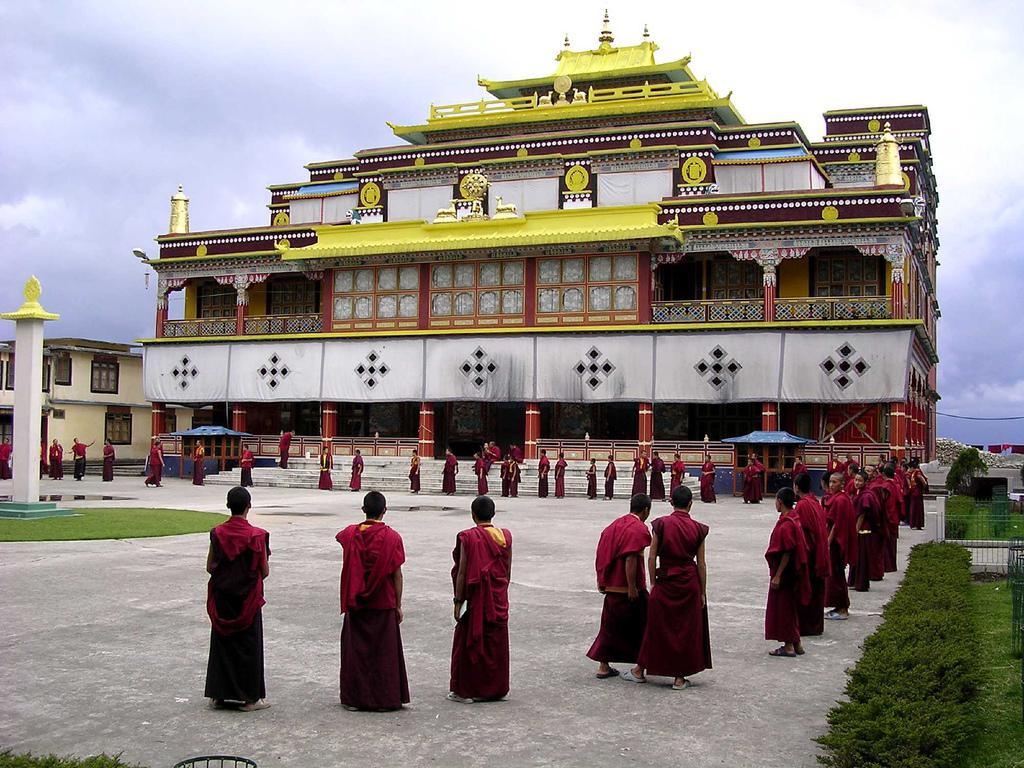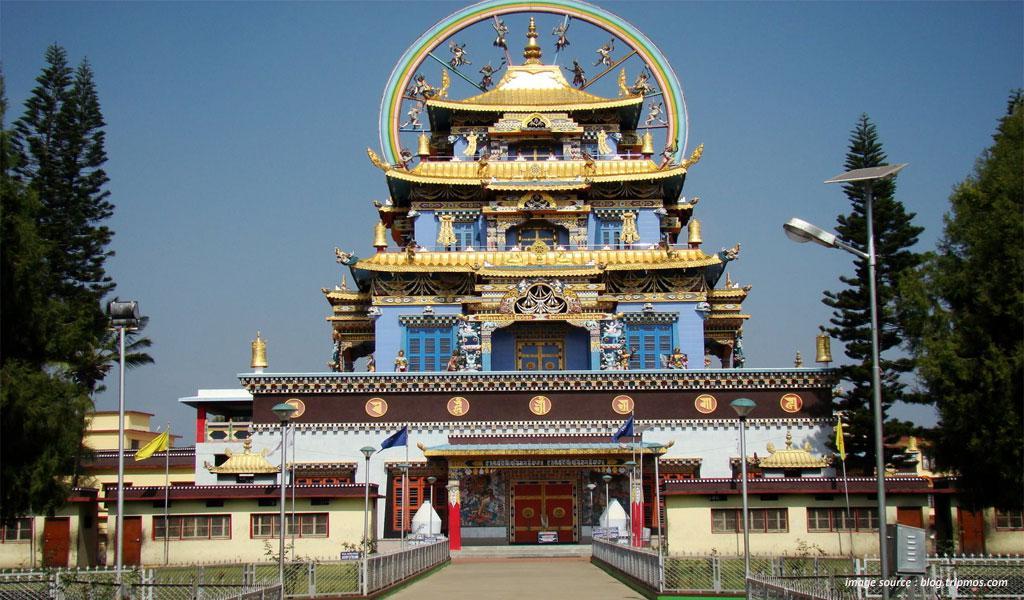The first image is the image on the left, the second image is the image on the right. For the images displayed, is the sentence "An image shows the exterior of a temple with bold, decorative symbols repeating across a white banner running the length of the building." factually correct? Answer yes or no. Yes. The first image is the image on the left, the second image is the image on the right. For the images shown, is this caption "The left and right image contains the same number of monasteries." true? Answer yes or no. Yes. 